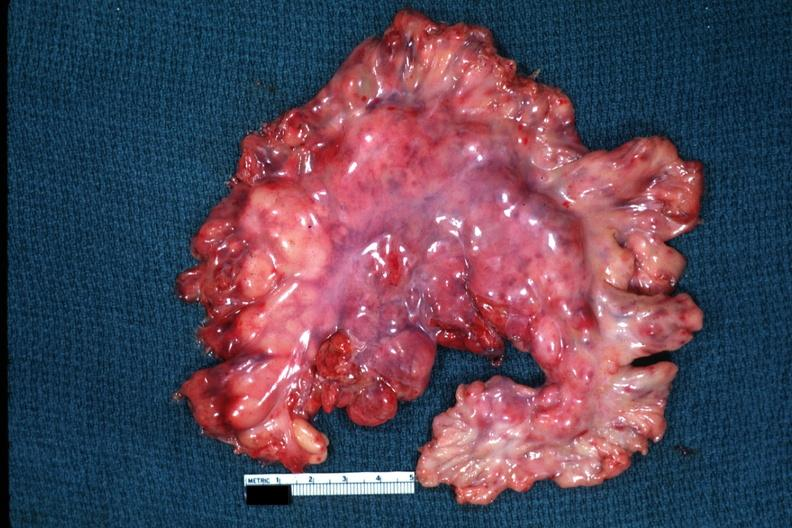s carcinomatosis present?
Answer the question using a single word or phrase. No 